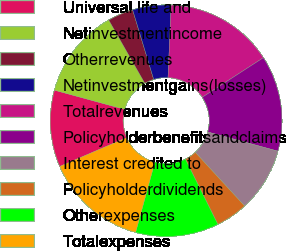<chart> <loc_0><loc_0><loc_500><loc_500><pie_chart><fcel>Universal life and<fcel>Netinvestmentincome<fcel>Otherrevenues<fcel>Netinvestmentgains(losses)<fcel>Totalrevenues<fcel>Policyholderbenefitsandclaims<fcel>Interest credited to<fcel>Policyholderdividends<fcel>Otherexpenses<fcel>Totalexpenses<nl><fcel>10.71%<fcel>12.5%<fcel>3.58%<fcel>5.36%<fcel>15.17%<fcel>13.39%<fcel>8.93%<fcel>4.47%<fcel>11.61%<fcel>14.28%<nl></chart> 